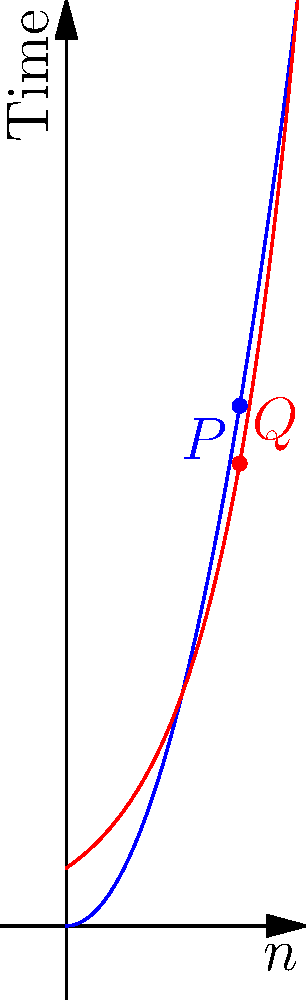Consider the computational complexity graph shown above, which compares two algorithms: one with time complexity $O(n^2)$ (blue curve) and another with $O(2^n)$ (red curve). At what approximate input size $n$ does the exponential-time algorithm begin to significantly outperform the polynomial-time algorithm in terms of running time? To determine when the exponential-time algorithm begins to significantly outperform the polynomial-time algorithm, we need to analyze the intersection point of the two curves:

1. The blue curve represents $f_1(n) = n^2$ (polynomial time)
2. The red curve represents $f_2(n) = 2^n$ (exponential time)

3. We need to solve the equation: $n^2 = 2^n$

4. This equation doesn't have a closed-form solution, but we can approximate it:
   - For $n = 3$: $3^2 = 9$, while $2^3 = 8$
   - For $n = 4$: $4^2 = 16$, while $2^4 = 16$
   - For $n > 4$: $2^n$ grows much faster than $n^2$

5. The intersection point is very close to $n = 4$

6. After this point, the exponential function grows much faster than the polynomial function

7. Therefore, for $n \geq 4$, the exponential-time algorithm begins to perform significantly worse than the polynomial-time algorithm

8. The graph visually confirms this analysis, showing the curves intersecting near $n = 4$, after which the red curve ($O(2^n)$) rises much more steeply than the blue curve ($O(n^2)$)
Answer: $n \approx 4$ 